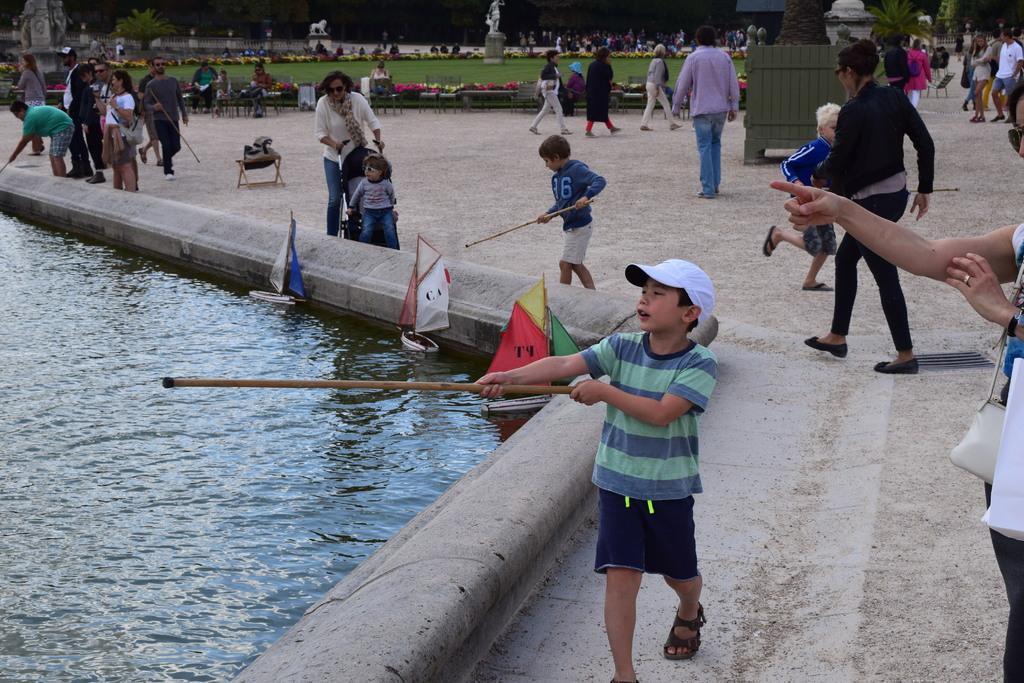How would you summarize this image in a sentence or two? In this picture we can see a boy holding a stick in his hand. We can see few boats in water. There is a bag on the chair. We can see some people are walking, some people are holding objects in their hands and few people are sitting on the benches. There are few statues, plants, and some fencing on the ground. 